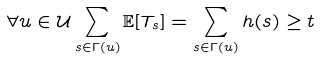Convert formula to latex. <formula><loc_0><loc_0><loc_500><loc_500>\forall u \in \mathcal { U } \sum _ { s \in \Gamma ( u ) } \mathbb { E } [ T _ { s } ] = \sum _ { s \in \Gamma ( u ) } h ( s ) \geq t</formula> 